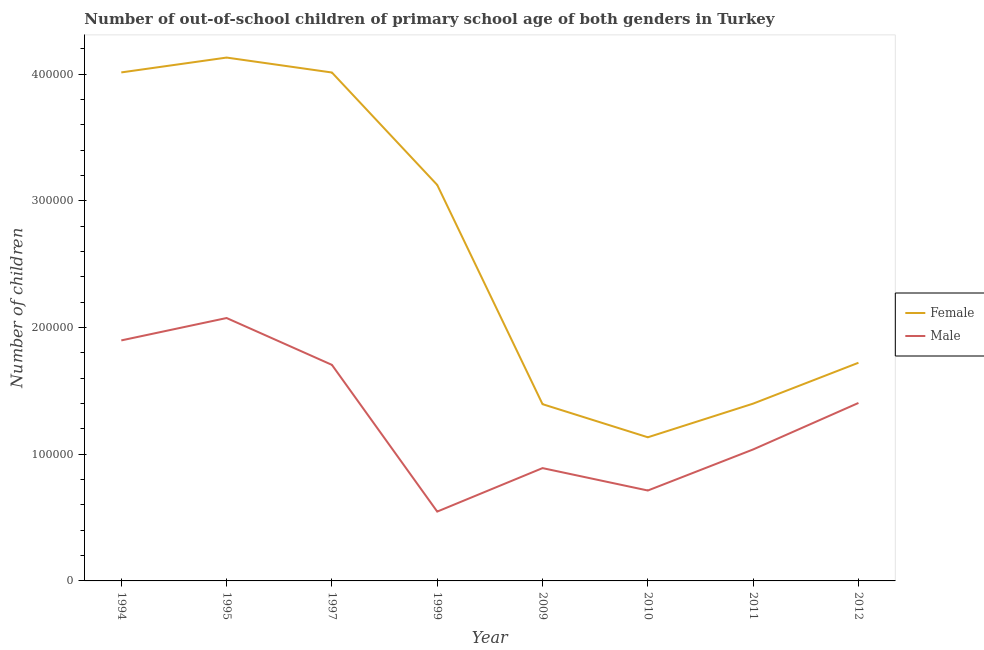How many different coloured lines are there?
Offer a terse response. 2. What is the number of female out-of-school students in 2010?
Offer a terse response. 1.13e+05. Across all years, what is the maximum number of female out-of-school students?
Provide a succinct answer. 4.13e+05. Across all years, what is the minimum number of female out-of-school students?
Offer a very short reply. 1.13e+05. In which year was the number of male out-of-school students minimum?
Your answer should be compact. 1999. What is the total number of female out-of-school students in the graph?
Give a very brief answer. 2.09e+06. What is the difference between the number of female out-of-school students in 1994 and that in 1999?
Provide a succinct answer. 8.88e+04. What is the difference between the number of male out-of-school students in 1999 and the number of female out-of-school students in 2012?
Give a very brief answer. -1.17e+05. What is the average number of male out-of-school students per year?
Your answer should be compact. 1.28e+05. In the year 2011, what is the difference between the number of female out-of-school students and number of male out-of-school students?
Make the answer very short. 3.62e+04. In how many years, is the number of female out-of-school students greater than 360000?
Offer a terse response. 3. What is the ratio of the number of male out-of-school students in 1997 to that in 2011?
Provide a succinct answer. 1.64. Is the number of female out-of-school students in 1994 less than that in 1999?
Keep it short and to the point. No. Is the difference between the number of male out-of-school students in 1994 and 1999 greater than the difference between the number of female out-of-school students in 1994 and 1999?
Your response must be concise. Yes. What is the difference between the highest and the second highest number of male out-of-school students?
Your response must be concise. 1.77e+04. What is the difference between the highest and the lowest number of male out-of-school students?
Provide a succinct answer. 1.53e+05. Is the sum of the number of female out-of-school students in 1995 and 2010 greater than the maximum number of male out-of-school students across all years?
Make the answer very short. Yes. Is the number of female out-of-school students strictly greater than the number of male out-of-school students over the years?
Offer a very short reply. Yes. How many lines are there?
Provide a succinct answer. 2. What is the difference between two consecutive major ticks on the Y-axis?
Provide a short and direct response. 1.00e+05. Does the graph contain any zero values?
Your answer should be compact. No. Where does the legend appear in the graph?
Provide a short and direct response. Center right. What is the title of the graph?
Give a very brief answer. Number of out-of-school children of primary school age of both genders in Turkey. What is the label or title of the X-axis?
Your answer should be compact. Year. What is the label or title of the Y-axis?
Your answer should be compact. Number of children. What is the Number of children in Female in 1994?
Your response must be concise. 4.01e+05. What is the Number of children in Male in 1994?
Provide a short and direct response. 1.90e+05. What is the Number of children in Female in 1995?
Offer a terse response. 4.13e+05. What is the Number of children of Male in 1995?
Your answer should be compact. 2.08e+05. What is the Number of children of Female in 1997?
Provide a succinct answer. 4.01e+05. What is the Number of children of Male in 1997?
Give a very brief answer. 1.71e+05. What is the Number of children in Female in 1999?
Your response must be concise. 3.13e+05. What is the Number of children in Male in 1999?
Offer a terse response. 5.47e+04. What is the Number of children in Female in 2009?
Your response must be concise. 1.40e+05. What is the Number of children in Male in 2009?
Your response must be concise. 8.90e+04. What is the Number of children of Female in 2010?
Your answer should be compact. 1.13e+05. What is the Number of children in Male in 2010?
Your answer should be very brief. 7.14e+04. What is the Number of children in Female in 2011?
Keep it short and to the point. 1.40e+05. What is the Number of children of Male in 2011?
Provide a succinct answer. 1.04e+05. What is the Number of children in Female in 2012?
Ensure brevity in your answer.  1.72e+05. What is the Number of children of Male in 2012?
Provide a succinct answer. 1.40e+05. Across all years, what is the maximum Number of children in Female?
Provide a succinct answer. 4.13e+05. Across all years, what is the maximum Number of children in Male?
Ensure brevity in your answer.  2.08e+05. Across all years, what is the minimum Number of children in Female?
Provide a short and direct response. 1.13e+05. Across all years, what is the minimum Number of children in Male?
Ensure brevity in your answer.  5.47e+04. What is the total Number of children in Female in the graph?
Make the answer very short. 2.09e+06. What is the total Number of children of Male in the graph?
Your answer should be very brief. 1.03e+06. What is the difference between the Number of children in Female in 1994 and that in 1995?
Your response must be concise. -1.17e+04. What is the difference between the Number of children in Male in 1994 and that in 1995?
Your response must be concise. -1.77e+04. What is the difference between the Number of children of Female in 1994 and that in 1997?
Offer a very short reply. 73. What is the difference between the Number of children in Male in 1994 and that in 1997?
Provide a succinct answer. 1.93e+04. What is the difference between the Number of children of Female in 1994 and that in 1999?
Offer a terse response. 8.88e+04. What is the difference between the Number of children of Male in 1994 and that in 1999?
Make the answer very short. 1.35e+05. What is the difference between the Number of children of Female in 1994 and that in 2009?
Ensure brevity in your answer.  2.62e+05. What is the difference between the Number of children in Male in 1994 and that in 2009?
Make the answer very short. 1.01e+05. What is the difference between the Number of children in Female in 1994 and that in 2010?
Keep it short and to the point. 2.88e+05. What is the difference between the Number of children of Male in 1994 and that in 2010?
Your response must be concise. 1.18e+05. What is the difference between the Number of children of Female in 1994 and that in 2011?
Provide a succinct answer. 2.61e+05. What is the difference between the Number of children in Male in 1994 and that in 2011?
Provide a succinct answer. 8.61e+04. What is the difference between the Number of children of Female in 1994 and that in 2012?
Offer a very short reply. 2.29e+05. What is the difference between the Number of children of Male in 1994 and that in 2012?
Ensure brevity in your answer.  4.94e+04. What is the difference between the Number of children in Female in 1995 and that in 1997?
Your answer should be very brief. 1.18e+04. What is the difference between the Number of children of Male in 1995 and that in 1997?
Your answer should be compact. 3.70e+04. What is the difference between the Number of children in Female in 1995 and that in 1999?
Provide a succinct answer. 1.01e+05. What is the difference between the Number of children in Male in 1995 and that in 1999?
Give a very brief answer. 1.53e+05. What is the difference between the Number of children in Female in 1995 and that in 2009?
Ensure brevity in your answer.  2.74e+05. What is the difference between the Number of children in Male in 1995 and that in 2009?
Keep it short and to the point. 1.18e+05. What is the difference between the Number of children of Female in 1995 and that in 2010?
Offer a terse response. 3.00e+05. What is the difference between the Number of children in Male in 1995 and that in 2010?
Your answer should be compact. 1.36e+05. What is the difference between the Number of children of Female in 1995 and that in 2011?
Ensure brevity in your answer.  2.73e+05. What is the difference between the Number of children in Male in 1995 and that in 2011?
Offer a very short reply. 1.04e+05. What is the difference between the Number of children in Female in 1995 and that in 2012?
Offer a very short reply. 2.41e+05. What is the difference between the Number of children in Male in 1995 and that in 2012?
Your response must be concise. 6.71e+04. What is the difference between the Number of children in Female in 1997 and that in 1999?
Offer a terse response. 8.87e+04. What is the difference between the Number of children in Male in 1997 and that in 1999?
Offer a terse response. 1.16e+05. What is the difference between the Number of children of Female in 1997 and that in 2009?
Keep it short and to the point. 2.62e+05. What is the difference between the Number of children in Male in 1997 and that in 2009?
Make the answer very short. 8.15e+04. What is the difference between the Number of children of Female in 1997 and that in 2010?
Provide a succinct answer. 2.88e+05. What is the difference between the Number of children in Male in 1997 and that in 2010?
Your answer should be very brief. 9.92e+04. What is the difference between the Number of children in Female in 1997 and that in 2011?
Provide a succinct answer. 2.61e+05. What is the difference between the Number of children in Male in 1997 and that in 2011?
Your answer should be very brief. 6.68e+04. What is the difference between the Number of children of Female in 1997 and that in 2012?
Your answer should be very brief. 2.29e+05. What is the difference between the Number of children of Male in 1997 and that in 2012?
Provide a succinct answer. 3.01e+04. What is the difference between the Number of children of Female in 1999 and that in 2009?
Provide a short and direct response. 1.73e+05. What is the difference between the Number of children of Male in 1999 and that in 2009?
Ensure brevity in your answer.  -3.43e+04. What is the difference between the Number of children in Female in 1999 and that in 2010?
Provide a succinct answer. 1.99e+05. What is the difference between the Number of children of Male in 1999 and that in 2010?
Provide a succinct answer. -1.66e+04. What is the difference between the Number of children in Female in 1999 and that in 2011?
Keep it short and to the point. 1.73e+05. What is the difference between the Number of children in Male in 1999 and that in 2011?
Your answer should be compact. -4.90e+04. What is the difference between the Number of children of Female in 1999 and that in 2012?
Give a very brief answer. 1.40e+05. What is the difference between the Number of children of Male in 1999 and that in 2012?
Offer a terse response. -8.57e+04. What is the difference between the Number of children in Female in 2009 and that in 2010?
Ensure brevity in your answer.  2.61e+04. What is the difference between the Number of children of Male in 2009 and that in 2010?
Your answer should be compact. 1.77e+04. What is the difference between the Number of children of Female in 2009 and that in 2011?
Offer a very short reply. -429. What is the difference between the Number of children in Male in 2009 and that in 2011?
Ensure brevity in your answer.  -1.47e+04. What is the difference between the Number of children of Female in 2009 and that in 2012?
Offer a terse response. -3.27e+04. What is the difference between the Number of children of Male in 2009 and that in 2012?
Your answer should be very brief. -5.14e+04. What is the difference between the Number of children of Female in 2010 and that in 2011?
Your answer should be compact. -2.66e+04. What is the difference between the Number of children of Male in 2010 and that in 2011?
Your answer should be compact. -3.24e+04. What is the difference between the Number of children in Female in 2010 and that in 2012?
Ensure brevity in your answer.  -5.88e+04. What is the difference between the Number of children in Male in 2010 and that in 2012?
Ensure brevity in your answer.  -6.91e+04. What is the difference between the Number of children in Female in 2011 and that in 2012?
Provide a succinct answer. -3.23e+04. What is the difference between the Number of children in Male in 2011 and that in 2012?
Your answer should be very brief. -3.67e+04. What is the difference between the Number of children of Female in 1994 and the Number of children of Male in 1995?
Your response must be concise. 1.94e+05. What is the difference between the Number of children of Female in 1994 and the Number of children of Male in 1997?
Offer a terse response. 2.31e+05. What is the difference between the Number of children in Female in 1994 and the Number of children in Male in 1999?
Offer a terse response. 3.47e+05. What is the difference between the Number of children in Female in 1994 and the Number of children in Male in 2009?
Ensure brevity in your answer.  3.12e+05. What is the difference between the Number of children in Female in 1994 and the Number of children in Male in 2010?
Give a very brief answer. 3.30e+05. What is the difference between the Number of children in Female in 1994 and the Number of children in Male in 2011?
Provide a short and direct response. 2.98e+05. What is the difference between the Number of children in Female in 1994 and the Number of children in Male in 2012?
Your response must be concise. 2.61e+05. What is the difference between the Number of children of Female in 1995 and the Number of children of Male in 1997?
Your response must be concise. 2.43e+05. What is the difference between the Number of children in Female in 1995 and the Number of children in Male in 1999?
Your response must be concise. 3.58e+05. What is the difference between the Number of children of Female in 1995 and the Number of children of Male in 2009?
Provide a succinct answer. 3.24e+05. What is the difference between the Number of children in Female in 1995 and the Number of children in Male in 2010?
Your answer should be very brief. 3.42e+05. What is the difference between the Number of children of Female in 1995 and the Number of children of Male in 2011?
Your answer should be compact. 3.09e+05. What is the difference between the Number of children of Female in 1995 and the Number of children of Male in 2012?
Provide a succinct answer. 2.73e+05. What is the difference between the Number of children in Female in 1997 and the Number of children in Male in 1999?
Ensure brevity in your answer.  3.47e+05. What is the difference between the Number of children of Female in 1997 and the Number of children of Male in 2009?
Make the answer very short. 3.12e+05. What is the difference between the Number of children of Female in 1997 and the Number of children of Male in 2010?
Give a very brief answer. 3.30e+05. What is the difference between the Number of children in Female in 1997 and the Number of children in Male in 2011?
Your response must be concise. 2.98e+05. What is the difference between the Number of children of Female in 1997 and the Number of children of Male in 2012?
Give a very brief answer. 2.61e+05. What is the difference between the Number of children of Female in 1999 and the Number of children of Male in 2009?
Offer a very short reply. 2.24e+05. What is the difference between the Number of children of Female in 1999 and the Number of children of Male in 2010?
Keep it short and to the point. 2.41e+05. What is the difference between the Number of children of Female in 1999 and the Number of children of Male in 2011?
Your answer should be compact. 2.09e+05. What is the difference between the Number of children in Female in 1999 and the Number of children in Male in 2012?
Your response must be concise. 1.72e+05. What is the difference between the Number of children of Female in 2009 and the Number of children of Male in 2010?
Provide a succinct answer. 6.82e+04. What is the difference between the Number of children in Female in 2009 and the Number of children in Male in 2011?
Your response must be concise. 3.57e+04. What is the difference between the Number of children in Female in 2009 and the Number of children in Male in 2012?
Offer a very short reply. -945. What is the difference between the Number of children in Female in 2010 and the Number of children in Male in 2011?
Give a very brief answer. 9601. What is the difference between the Number of children of Female in 2010 and the Number of children of Male in 2012?
Make the answer very short. -2.71e+04. What is the difference between the Number of children in Female in 2011 and the Number of children in Male in 2012?
Your response must be concise. -516. What is the average Number of children of Female per year?
Offer a very short reply. 2.62e+05. What is the average Number of children in Male per year?
Your answer should be compact. 1.28e+05. In the year 1994, what is the difference between the Number of children of Female and Number of children of Male?
Provide a succinct answer. 2.12e+05. In the year 1995, what is the difference between the Number of children of Female and Number of children of Male?
Ensure brevity in your answer.  2.06e+05. In the year 1997, what is the difference between the Number of children in Female and Number of children in Male?
Give a very brief answer. 2.31e+05. In the year 1999, what is the difference between the Number of children of Female and Number of children of Male?
Give a very brief answer. 2.58e+05. In the year 2009, what is the difference between the Number of children in Female and Number of children in Male?
Keep it short and to the point. 5.05e+04. In the year 2010, what is the difference between the Number of children in Female and Number of children in Male?
Provide a succinct answer. 4.20e+04. In the year 2011, what is the difference between the Number of children in Female and Number of children in Male?
Provide a short and direct response. 3.62e+04. In the year 2012, what is the difference between the Number of children of Female and Number of children of Male?
Offer a terse response. 3.17e+04. What is the ratio of the Number of children in Female in 1994 to that in 1995?
Keep it short and to the point. 0.97. What is the ratio of the Number of children of Male in 1994 to that in 1995?
Give a very brief answer. 0.91. What is the ratio of the Number of children in Male in 1994 to that in 1997?
Your answer should be compact. 1.11. What is the ratio of the Number of children of Female in 1994 to that in 1999?
Provide a succinct answer. 1.28. What is the ratio of the Number of children in Male in 1994 to that in 1999?
Provide a short and direct response. 3.47. What is the ratio of the Number of children in Female in 1994 to that in 2009?
Offer a terse response. 2.88. What is the ratio of the Number of children of Male in 1994 to that in 2009?
Make the answer very short. 2.13. What is the ratio of the Number of children in Female in 1994 to that in 2010?
Provide a succinct answer. 3.54. What is the ratio of the Number of children in Male in 1994 to that in 2010?
Keep it short and to the point. 2.66. What is the ratio of the Number of children in Female in 1994 to that in 2011?
Keep it short and to the point. 2.87. What is the ratio of the Number of children in Male in 1994 to that in 2011?
Offer a terse response. 1.83. What is the ratio of the Number of children in Female in 1994 to that in 2012?
Your response must be concise. 2.33. What is the ratio of the Number of children of Male in 1994 to that in 2012?
Offer a very short reply. 1.35. What is the ratio of the Number of children of Female in 1995 to that in 1997?
Your response must be concise. 1.03. What is the ratio of the Number of children of Male in 1995 to that in 1997?
Keep it short and to the point. 1.22. What is the ratio of the Number of children in Female in 1995 to that in 1999?
Your answer should be compact. 1.32. What is the ratio of the Number of children in Male in 1995 to that in 1999?
Give a very brief answer. 3.79. What is the ratio of the Number of children of Female in 1995 to that in 2009?
Your response must be concise. 2.96. What is the ratio of the Number of children in Male in 1995 to that in 2009?
Your response must be concise. 2.33. What is the ratio of the Number of children in Female in 1995 to that in 2010?
Your answer should be very brief. 3.64. What is the ratio of the Number of children of Male in 1995 to that in 2010?
Provide a succinct answer. 2.91. What is the ratio of the Number of children in Female in 1995 to that in 2011?
Your response must be concise. 2.95. What is the ratio of the Number of children in Male in 1995 to that in 2011?
Offer a terse response. 2. What is the ratio of the Number of children of Female in 1995 to that in 2012?
Offer a terse response. 2.4. What is the ratio of the Number of children in Male in 1995 to that in 2012?
Keep it short and to the point. 1.48. What is the ratio of the Number of children of Female in 1997 to that in 1999?
Make the answer very short. 1.28. What is the ratio of the Number of children in Male in 1997 to that in 1999?
Keep it short and to the point. 3.12. What is the ratio of the Number of children of Female in 1997 to that in 2009?
Provide a succinct answer. 2.88. What is the ratio of the Number of children of Male in 1997 to that in 2009?
Give a very brief answer. 1.92. What is the ratio of the Number of children in Female in 1997 to that in 2010?
Provide a short and direct response. 3.54. What is the ratio of the Number of children in Male in 1997 to that in 2010?
Your response must be concise. 2.39. What is the ratio of the Number of children in Female in 1997 to that in 2011?
Your answer should be very brief. 2.87. What is the ratio of the Number of children of Male in 1997 to that in 2011?
Make the answer very short. 1.64. What is the ratio of the Number of children of Female in 1997 to that in 2012?
Ensure brevity in your answer.  2.33. What is the ratio of the Number of children in Male in 1997 to that in 2012?
Offer a terse response. 1.21. What is the ratio of the Number of children of Female in 1999 to that in 2009?
Provide a short and direct response. 2.24. What is the ratio of the Number of children of Male in 1999 to that in 2009?
Provide a succinct answer. 0.61. What is the ratio of the Number of children in Female in 1999 to that in 2010?
Offer a very short reply. 2.76. What is the ratio of the Number of children of Male in 1999 to that in 2010?
Give a very brief answer. 0.77. What is the ratio of the Number of children in Female in 1999 to that in 2011?
Ensure brevity in your answer.  2.23. What is the ratio of the Number of children of Male in 1999 to that in 2011?
Provide a succinct answer. 0.53. What is the ratio of the Number of children of Female in 1999 to that in 2012?
Your answer should be compact. 1.82. What is the ratio of the Number of children of Male in 1999 to that in 2012?
Your answer should be very brief. 0.39. What is the ratio of the Number of children in Female in 2009 to that in 2010?
Offer a very short reply. 1.23. What is the ratio of the Number of children in Male in 2009 to that in 2010?
Provide a succinct answer. 1.25. What is the ratio of the Number of children of Male in 2009 to that in 2011?
Ensure brevity in your answer.  0.86. What is the ratio of the Number of children in Female in 2009 to that in 2012?
Provide a succinct answer. 0.81. What is the ratio of the Number of children of Male in 2009 to that in 2012?
Keep it short and to the point. 0.63. What is the ratio of the Number of children in Female in 2010 to that in 2011?
Your response must be concise. 0.81. What is the ratio of the Number of children in Male in 2010 to that in 2011?
Give a very brief answer. 0.69. What is the ratio of the Number of children in Female in 2010 to that in 2012?
Make the answer very short. 0.66. What is the ratio of the Number of children in Male in 2010 to that in 2012?
Provide a short and direct response. 0.51. What is the ratio of the Number of children of Female in 2011 to that in 2012?
Your response must be concise. 0.81. What is the ratio of the Number of children in Male in 2011 to that in 2012?
Make the answer very short. 0.74. What is the difference between the highest and the second highest Number of children in Female?
Keep it short and to the point. 1.17e+04. What is the difference between the highest and the second highest Number of children of Male?
Give a very brief answer. 1.77e+04. What is the difference between the highest and the lowest Number of children in Female?
Your answer should be very brief. 3.00e+05. What is the difference between the highest and the lowest Number of children of Male?
Provide a succinct answer. 1.53e+05. 